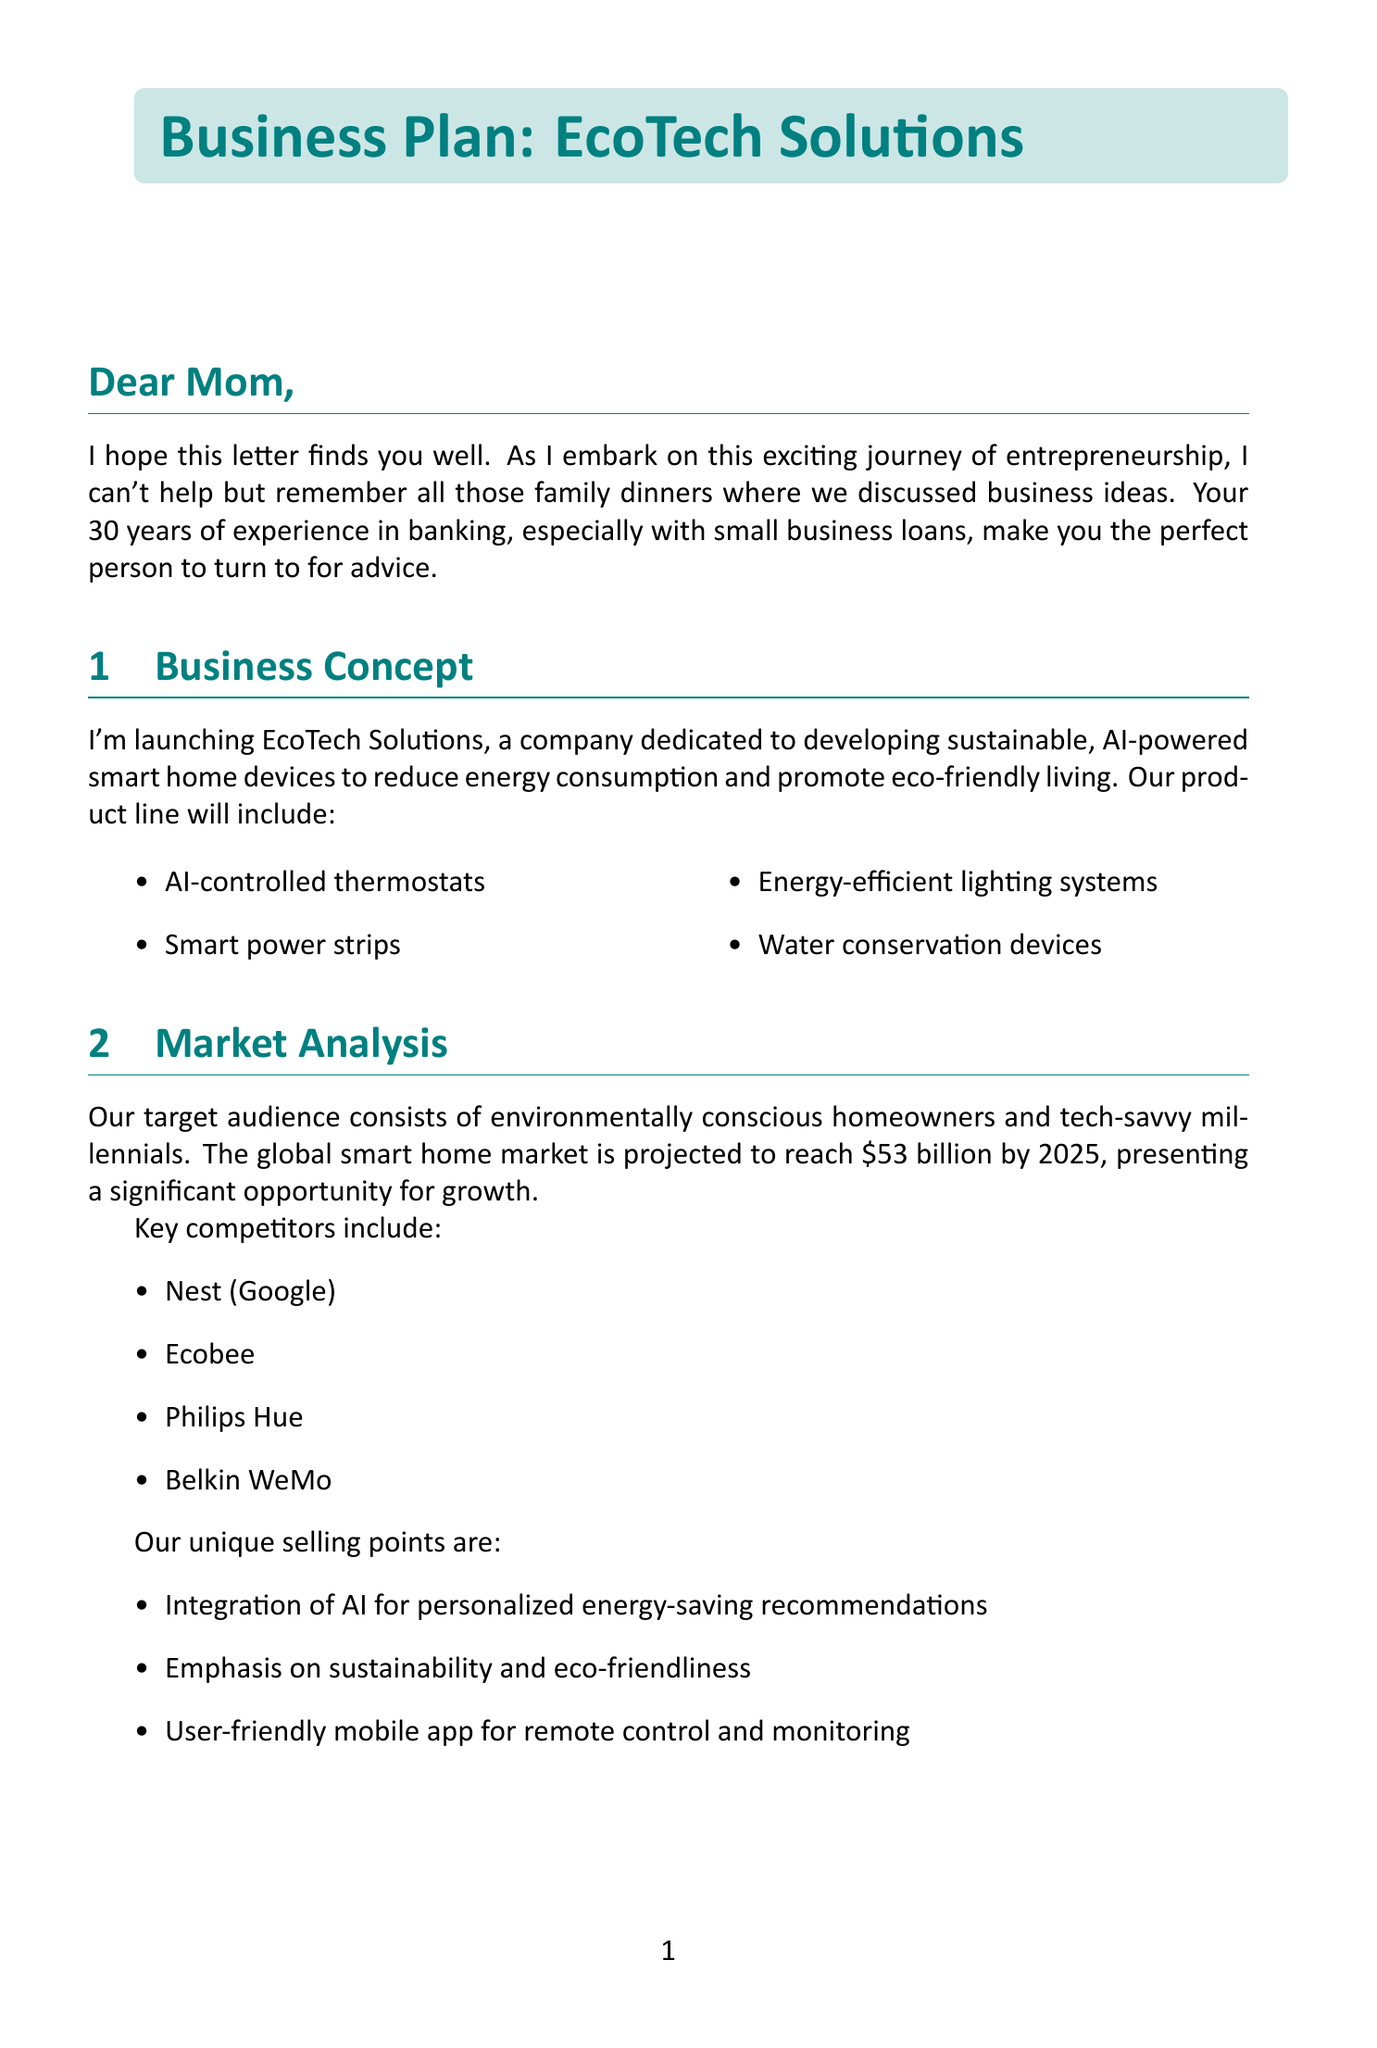What is the name of the company? The name of the company is mentioned in the Business Concept section of the document.
Answer: EcoTech Solutions What is the target audience? The target audience is specified in the Market Analysis section, focusing on who the products are aimed at.
Answer: Environmentally conscious homeowners and tech-savvy millennials What is the projected revenue for Year 2? The projected revenue for Year 2 is listed under Financial Projections.
Answer: $2,000,000 What are the startup costs? The startup costs can be found in the Financial Projections section, detailing initial investment requirements.
Answer: $500,000 What is the breakeven point? The breakeven point is stated in the Financial Projections and indicates how long it will take to cover initial expenses.
Answer: 18 months What unique selling point emphasizes AI? This involves reasoning over the unique selling points listed in the Market Analysis section that highlight product features.
Answer: Integration of AI for personalized energy-saving recommendations What sources of funding are mentioned? The funding sources are listed in the Financial Projections part, outlining how the startup plans to finance itself.
Answer: Personal savings, Angel investors, Kickstarter campaign What aspect of life influenced the entrepreneur's business discussions? This relates to personal touches mentioned in the letter that illustrate the background influence on business ideas.
Answer: Family dinners What kind of devices is EcoTech Solutions developing? This question looks for specific product information provided in the Business Concept section.
Answer: Sustainable, AI-powered smart home devices 